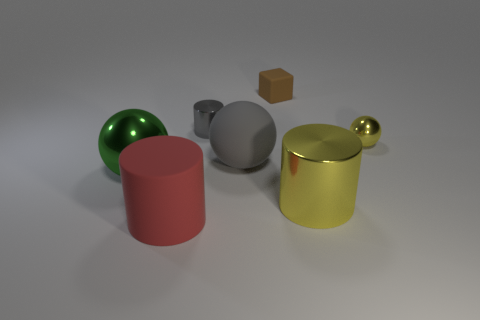Is the shape of the tiny yellow shiny object the same as the large green object?
Ensure brevity in your answer.  Yes. How many things are either rubber objects behind the big gray rubber thing or tiny purple metallic cylinders?
Offer a terse response. 1. Are there the same number of small brown blocks in front of the big green metal object and tiny brown matte things on the right side of the tiny brown cube?
Your response must be concise. Yes. How many other things are the same shape as the brown matte object?
Provide a short and direct response. 0. Does the yellow metallic thing that is behind the green metal thing have the same size as the gray metallic object to the right of the red thing?
Your answer should be very brief. Yes. How many blocks are either small red matte objects or brown matte things?
Ensure brevity in your answer.  1. How many matte things are yellow spheres or gray balls?
Give a very brief answer. 1. What size is the matte object that is the same shape as the tiny gray metal thing?
Make the answer very short. Large. There is a block; is its size the same as the yellow object behind the large shiny cylinder?
Your answer should be very brief. Yes. What is the shape of the large rubber thing behind the big red cylinder?
Make the answer very short. Sphere. 